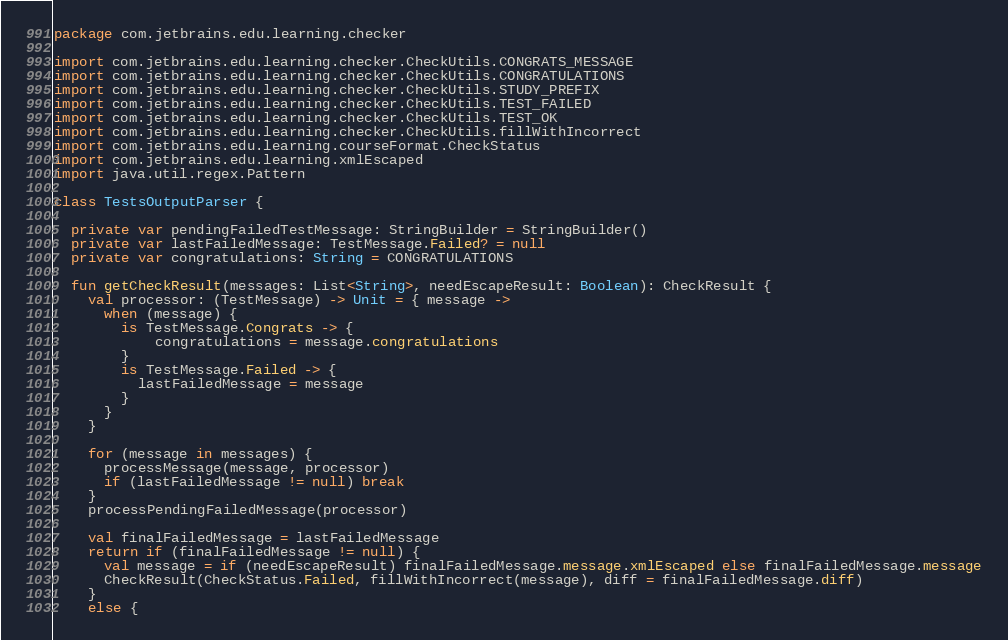Convert code to text. <code><loc_0><loc_0><loc_500><loc_500><_Kotlin_>package com.jetbrains.edu.learning.checker

import com.jetbrains.edu.learning.checker.CheckUtils.CONGRATS_MESSAGE
import com.jetbrains.edu.learning.checker.CheckUtils.CONGRATULATIONS
import com.jetbrains.edu.learning.checker.CheckUtils.STUDY_PREFIX
import com.jetbrains.edu.learning.checker.CheckUtils.TEST_FAILED
import com.jetbrains.edu.learning.checker.CheckUtils.TEST_OK
import com.jetbrains.edu.learning.checker.CheckUtils.fillWithIncorrect
import com.jetbrains.edu.learning.courseFormat.CheckStatus
import com.jetbrains.edu.learning.xmlEscaped
import java.util.regex.Pattern

class TestsOutputParser {

  private var pendingFailedTestMessage: StringBuilder = StringBuilder()
  private var lastFailedMessage: TestMessage.Failed? = null
  private var congratulations: String = CONGRATULATIONS

  fun getCheckResult(messages: List<String>, needEscapeResult: Boolean): CheckResult {
    val processor: (TestMessage) -> Unit = { message ->
      when (message) {
        is TestMessage.Congrats -> {
            congratulations = message.congratulations
        }
        is TestMessage.Failed -> {
          lastFailedMessage = message
        }
      }
    }

    for (message in messages) {
      processMessage(message, processor)
      if (lastFailedMessage != null) break
    }
    processPendingFailedMessage(processor)

    val finalFailedMessage = lastFailedMessage
    return if (finalFailedMessage != null) {
      val message = if (needEscapeResult) finalFailedMessage.message.xmlEscaped else finalFailedMessage.message
      CheckResult(CheckStatus.Failed, fillWithIncorrect(message), diff = finalFailedMessage.diff)
    }
    else {</code> 